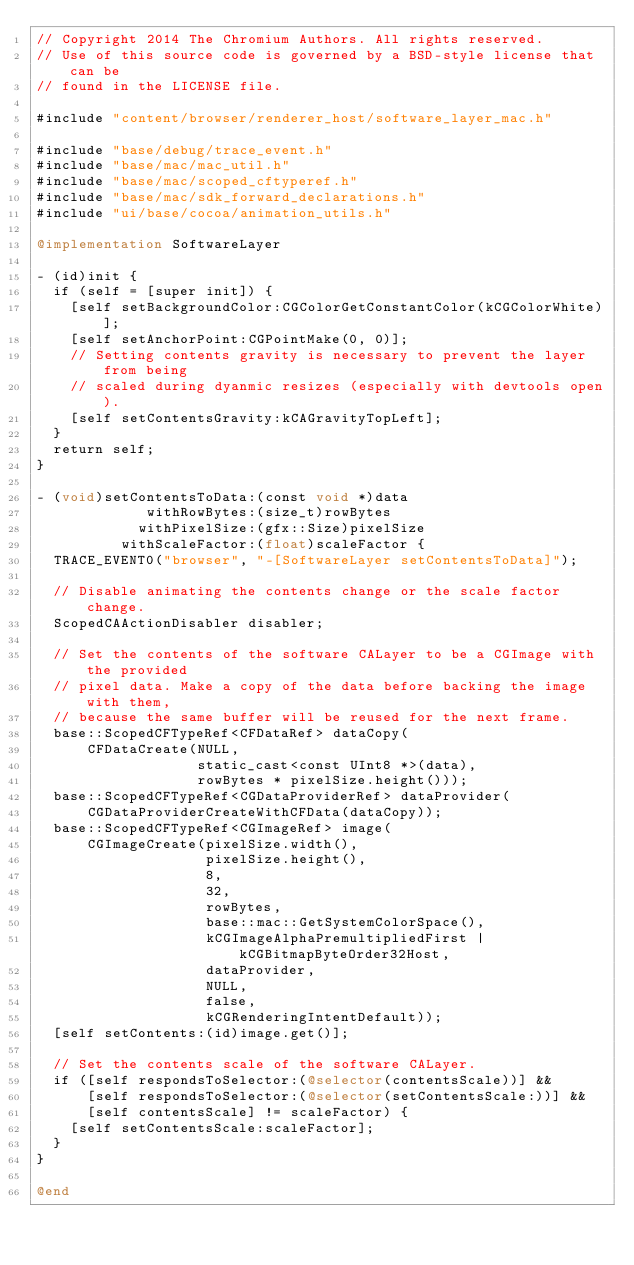<code> <loc_0><loc_0><loc_500><loc_500><_ObjectiveC_>// Copyright 2014 The Chromium Authors. All rights reserved.
// Use of this source code is governed by a BSD-style license that can be
// found in the LICENSE file.

#include "content/browser/renderer_host/software_layer_mac.h"

#include "base/debug/trace_event.h"
#include "base/mac/mac_util.h"
#include "base/mac/scoped_cftyperef.h"
#include "base/mac/sdk_forward_declarations.h"
#include "ui/base/cocoa/animation_utils.h"

@implementation SoftwareLayer

- (id)init {
  if (self = [super init]) {
    [self setBackgroundColor:CGColorGetConstantColor(kCGColorWhite)];
    [self setAnchorPoint:CGPointMake(0, 0)];
    // Setting contents gravity is necessary to prevent the layer from being
    // scaled during dyanmic resizes (especially with devtools open).
    [self setContentsGravity:kCAGravityTopLeft];
  }
  return self;
}

- (void)setContentsToData:(const void *)data
             withRowBytes:(size_t)rowBytes
            withPixelSize:(gfx::Size)pixelSize
          withScaleFactor:(float)scaleFactor {
  TRACE_EVENT0("browser", "-[SoftwareLayer setContentsToData]");

  // Disable animating the contents change or the scale factor change.
  ScopedCAActionDisabler disabler;

  // Set the contents of the software CALayer to be a CGImage with the provided
  // pixel data. Make a copy of the data before backing the image with them,
  // because the same buffer will be reused for the next frame.
  base::ScopedCFTypeRef<CFDataRef> dataCopy(
      CFDataCreate(NULL,
                   static_cast<const UInt8 *>(data),
                   rowBytes * pixelSize.height()));
  base::ScopedCFTypeRef<CGDataProviderRef> dataProvider(
      CGDataProviderCreateWithCFData(dataCopy));
  base::ScopedCFTypeRef<CGImageRef> image(
      CGImageCreate(pixelSize.width(),
                    pixelSize.height(),
                    8,
                    32,
                    rowBytes,
                    base::mac::GetSystemColorSpace(),
                    kCGImageAlphaPremultipliedFirst | kCGBitmapByteOrder32Host,
                    dataProvider,
                    NULL,
                    false,
                    kCGRenderingIntentDefault));
  [self setContents:(id)image.get()];

  // Set the contents scale of the software CALayer.
  if ([self respondsToSelector:(@selector(contentsScale))] &&
      [self respondsToSelector:(@selector(setContentsScale:))] &&
      [self contentsScale] != scaleFactor) {
    [self setContentsScale:scaleFactor];
  }
}

@end
</code> 